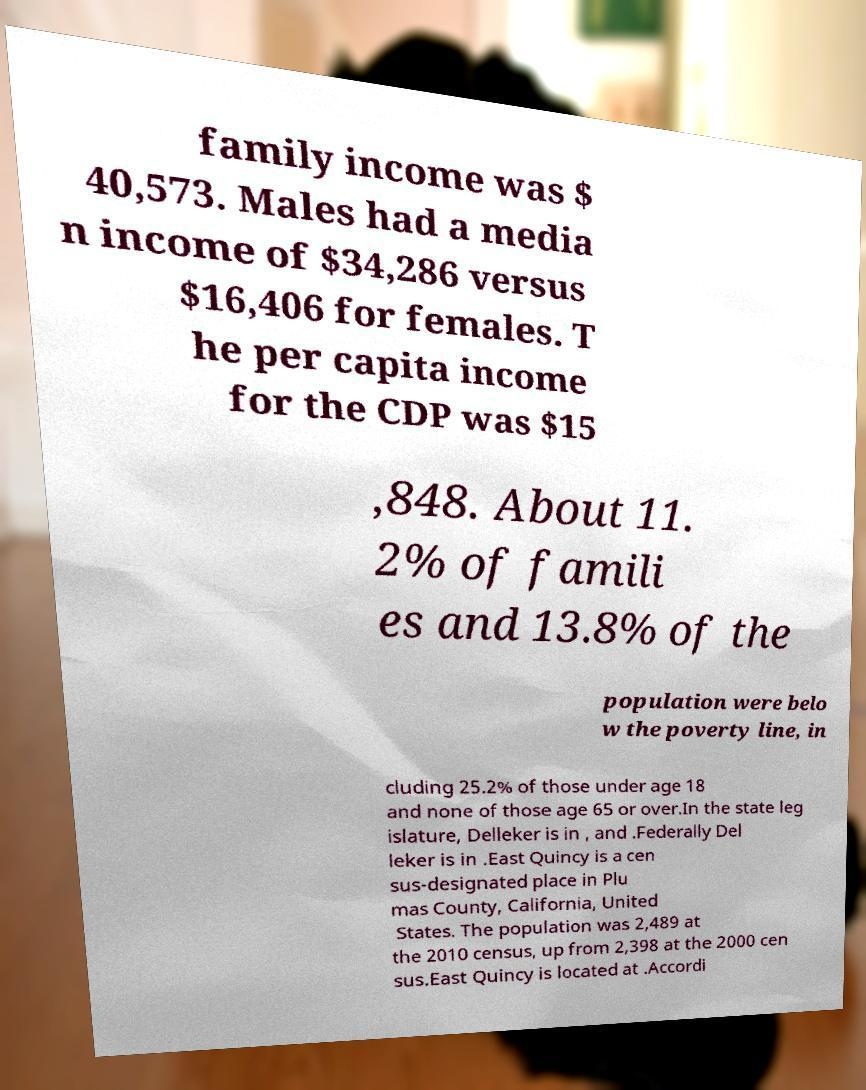Could you assist in decoding the text presented in this image and type it out clearly? family income was $ 40,573. Males had a media n income of $34,286 versus $16,406 for females. T he per capita income for the CDP was $15 ,848. About 11. 2% of famili es and 13.8% of the population were belo w the poverty line, in cluding 25.2% of those under age 18 and none of those age 65 or over.In the state leg islature, Delleker is in , and .Federally Del leker is in .East Quincy is a cen sus-designated place in Plu mas County, California, United States. The population was 2,489 at the 2010 census, up from 2,398 at the 2000 cen sus.East Quincy is located at .Accordi 